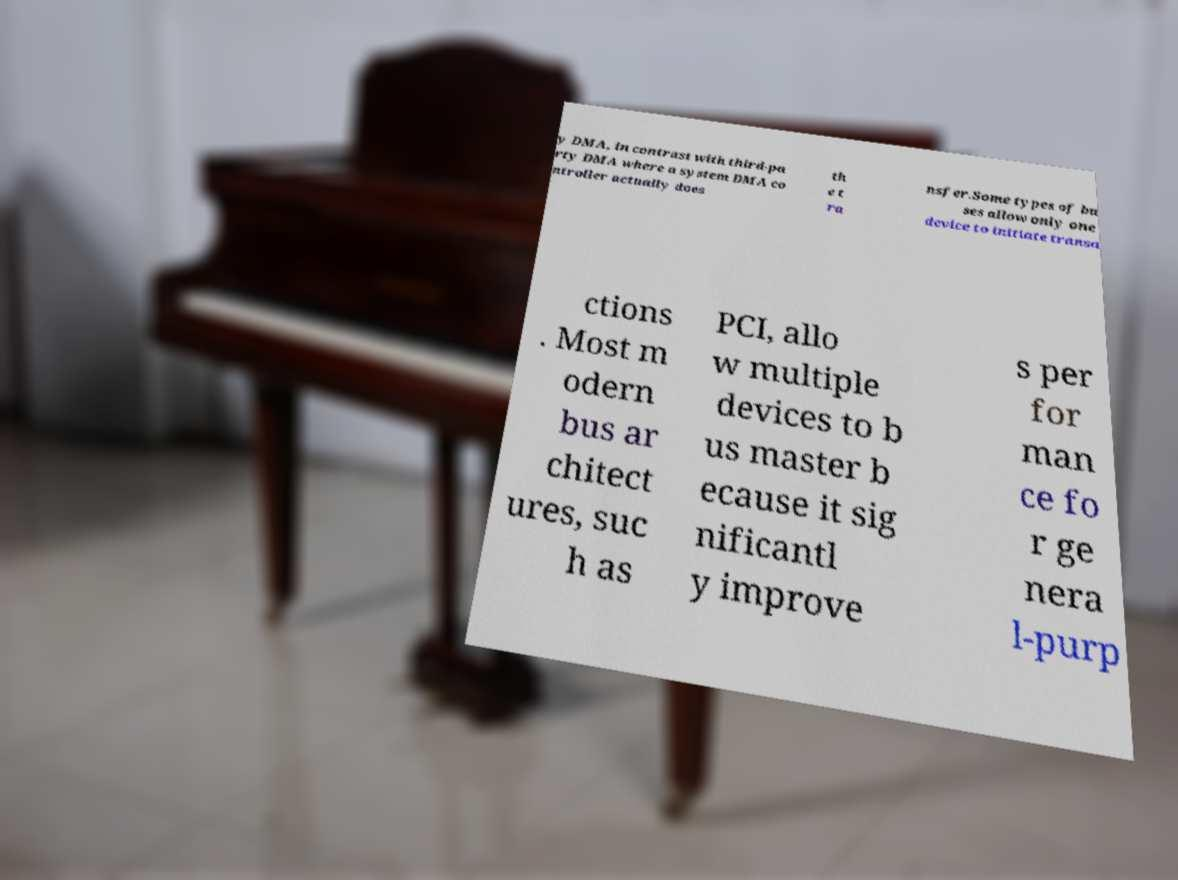Could you extract and type out the text from this image? y DMA, in contrast with third-pa rty DMA where a system DMA co ntroller actually does th e t ra nsfer.Some types of bu ses allow only one device to initiate transa ctions . Most m odern bus ar chitect ures, suc h as PCI, allo w multiple devices to b us master b ecause it sig nificantl y improve s per for man ce fo r ge nera l-purp 